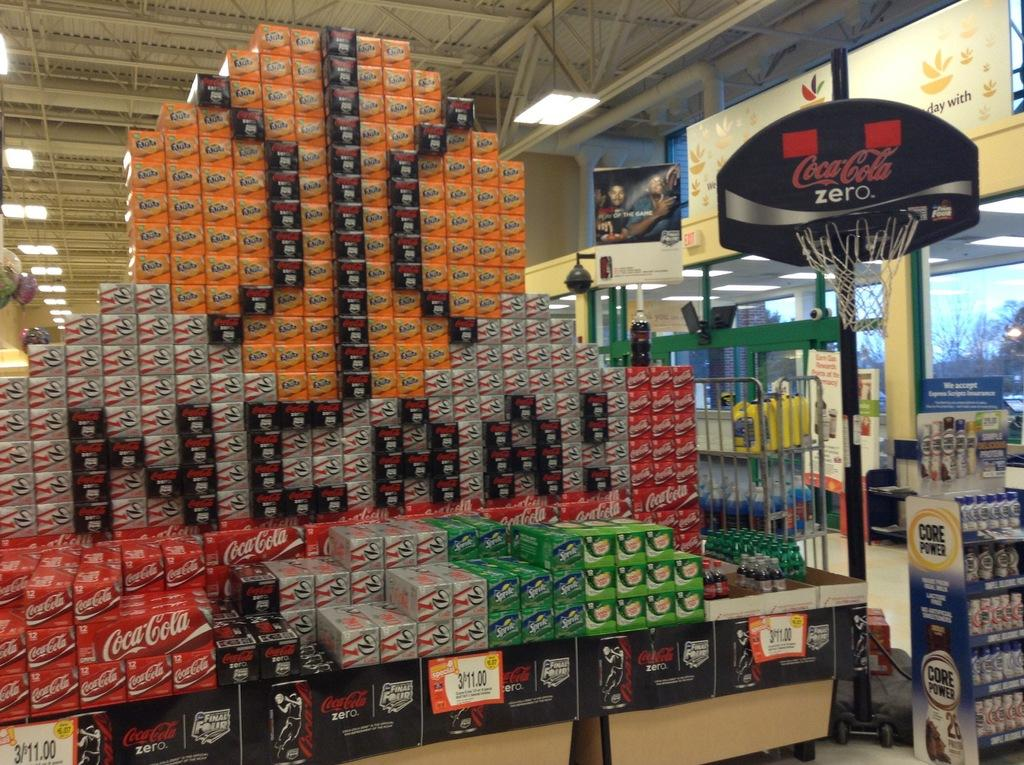<image>
Relay a brief, clear account of the picture shown. NCAA is displayed from soda boxes at this supermarket. 